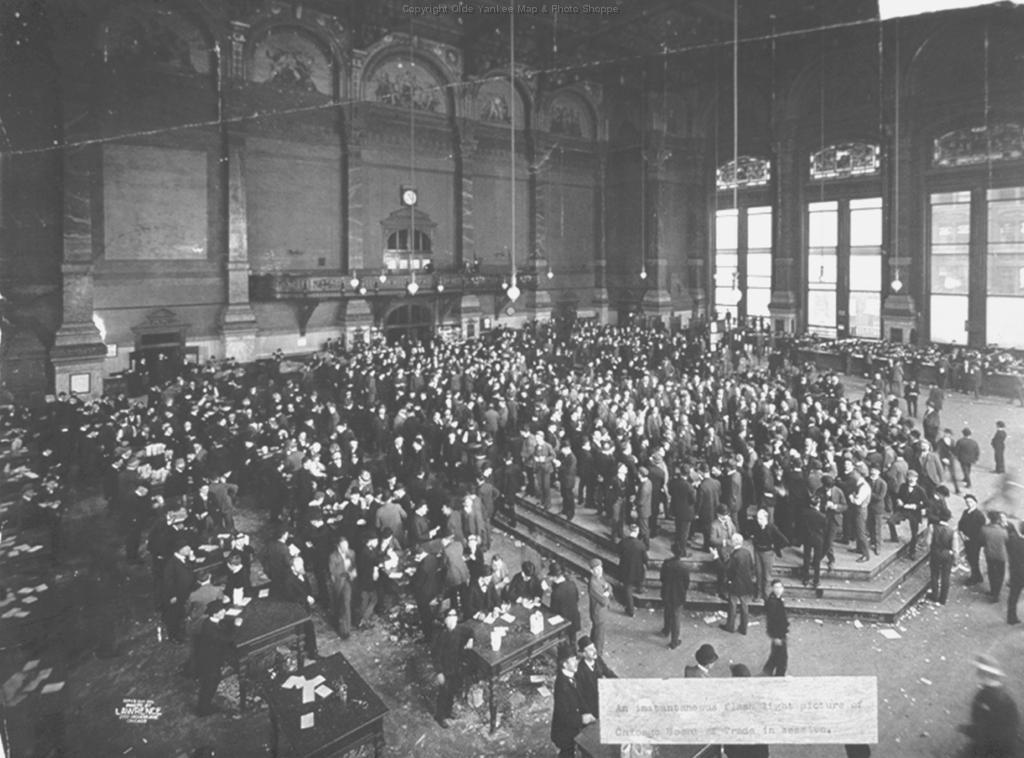Can you describe this image briefly? It is a black and white picture. In the center of the image we can see a group of people are standing and they are in different costumes. And we can see tables, papers, one board and staircase. In the background there is a wall, pillars, hanging lamps and a few other objects. 